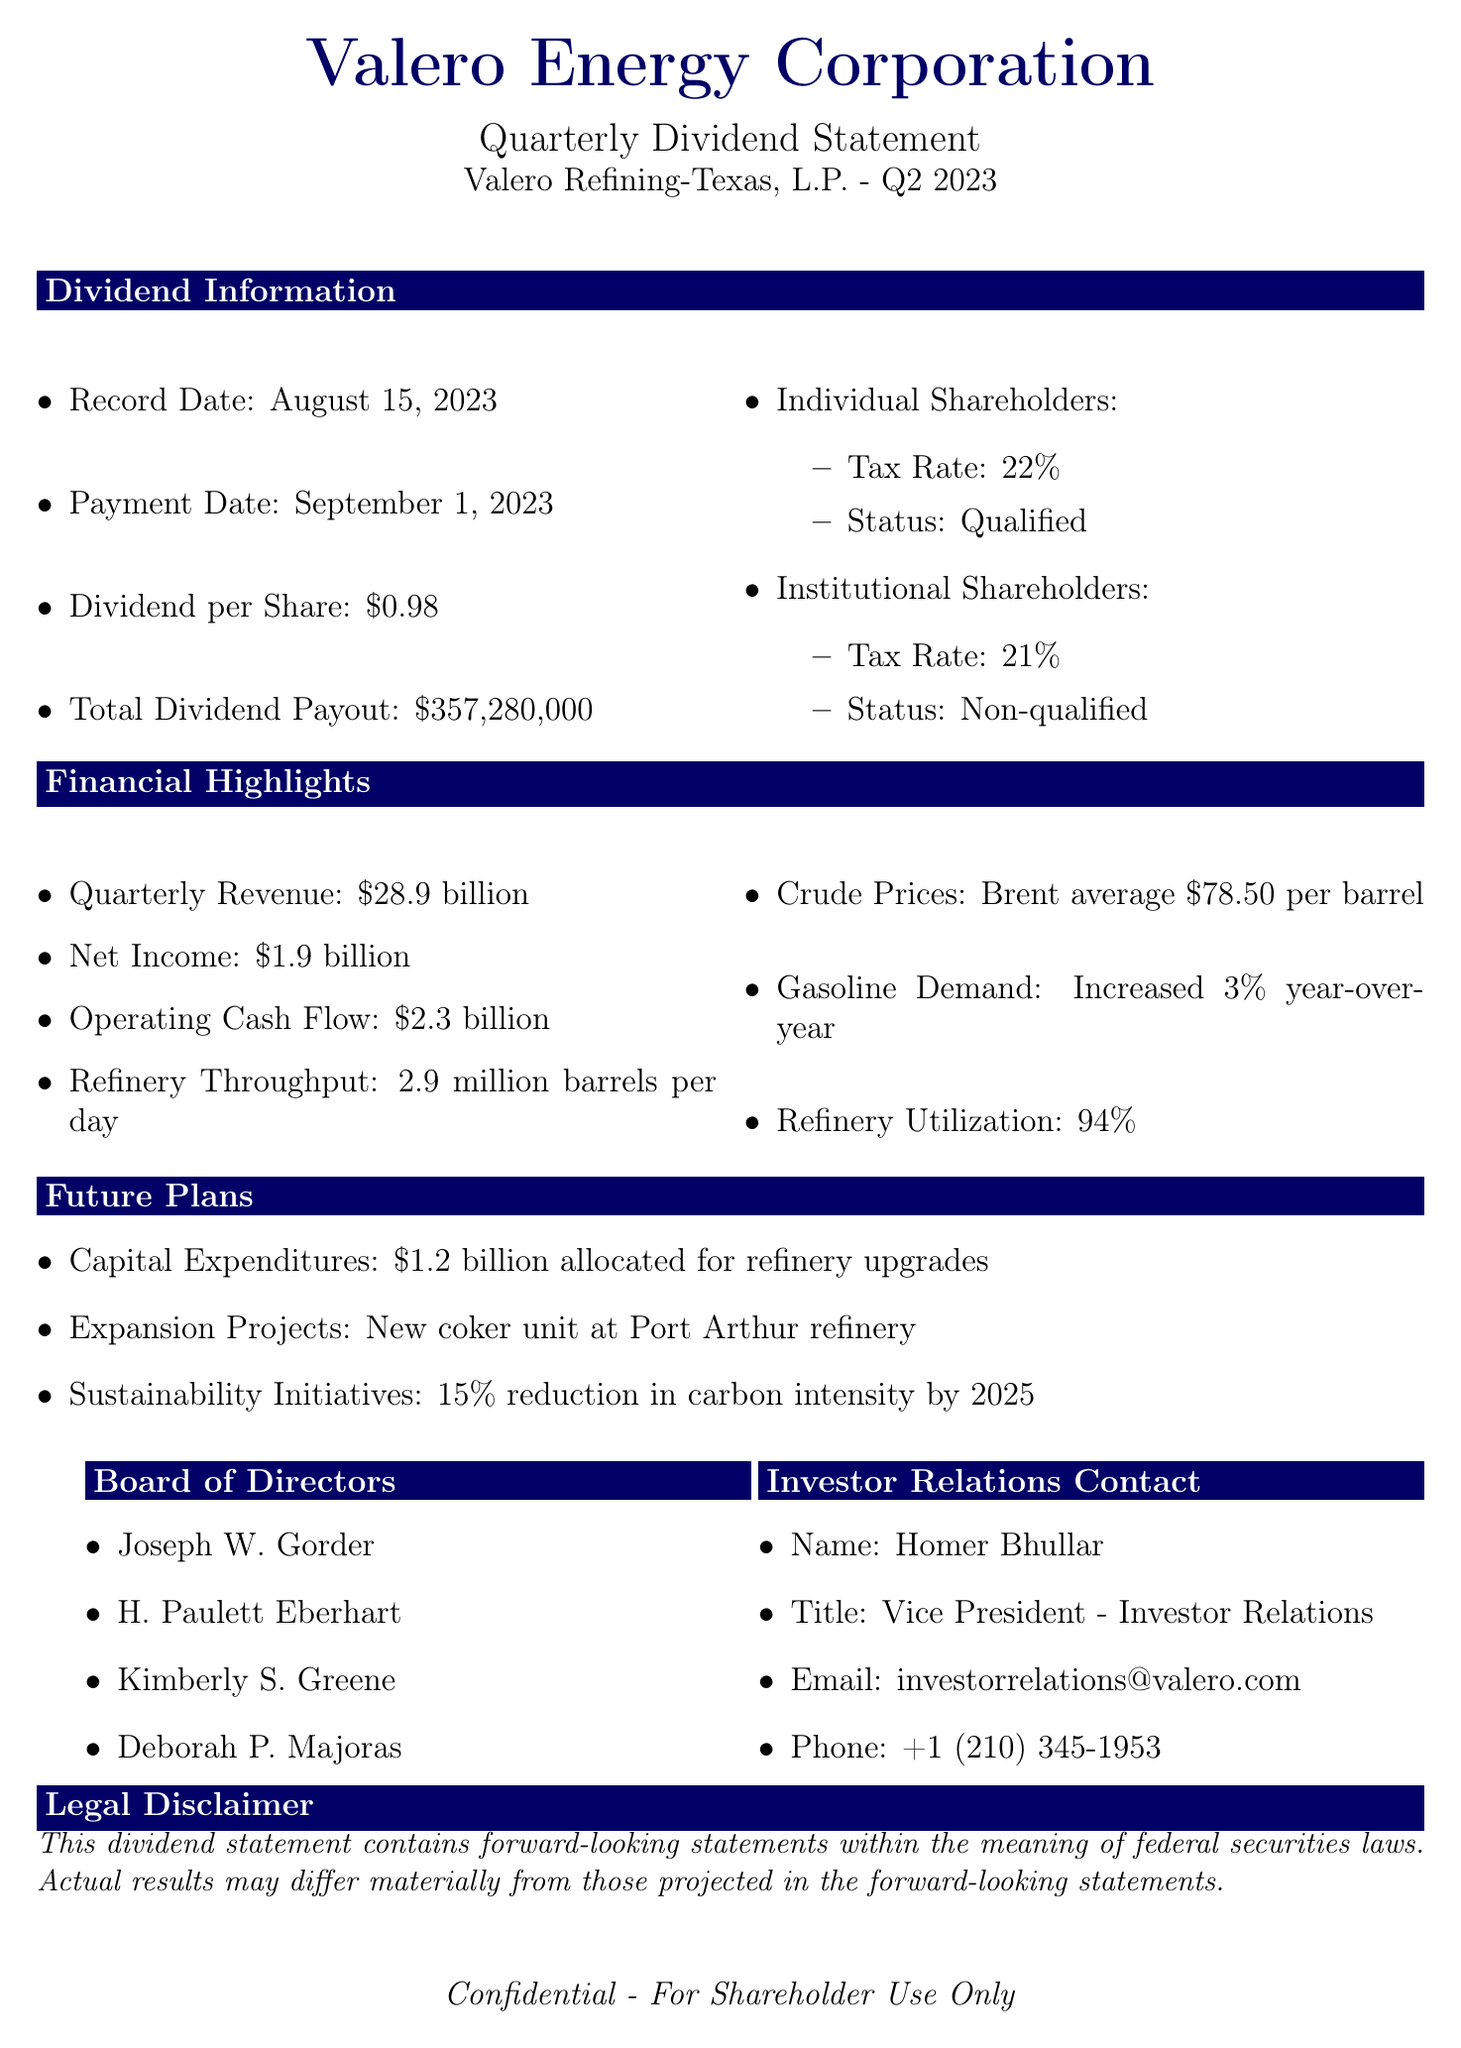What is the name of the subsidiary? The subsidiary name is explicitly mentioned as Valero Refining-Texas, L.P. in the document.
Answer: Valero Refining-Texas, L.P What is the total dividend payout? The total dividend payout is clearly stated in the document as $357,280,000.
Answer: $357,280,000 When is the payment date? The payment date is specifically indicated as September 1, 2023.
Answer: September 1, 2023 What percentage tax rate do individual shareholders face? The tax rate for individual shareholders is given as 22% in the dividend statement.
Answer: 22% What is the quarterly revenue reported? The document lists the quarterly revenue as $28.9 billion, which can be directly referenced.
Answer: $28.9 billion How much capital expenditure is allocated for refinery upgrades? The amount allocated for capital expenditures is detailed as $1.2 billion in the future plans section.
Answer: $1.2 billion What is the increased gasoline demand percentage year-over-year? The document states that gasoline demand has increased by 3% year-over-year.
Answer: 3% Which board member is the Vice President of Investor Relations? The Vice President of Investor Relations is named as Homer Bhullar in the investor relations contact section.
Answer: Homer Bhullar What is the status of dividends for institutional shareholders? The document specifies that the qualified dividend status for institutional shareholders is non-qualified.
Answer: Non-qualified 